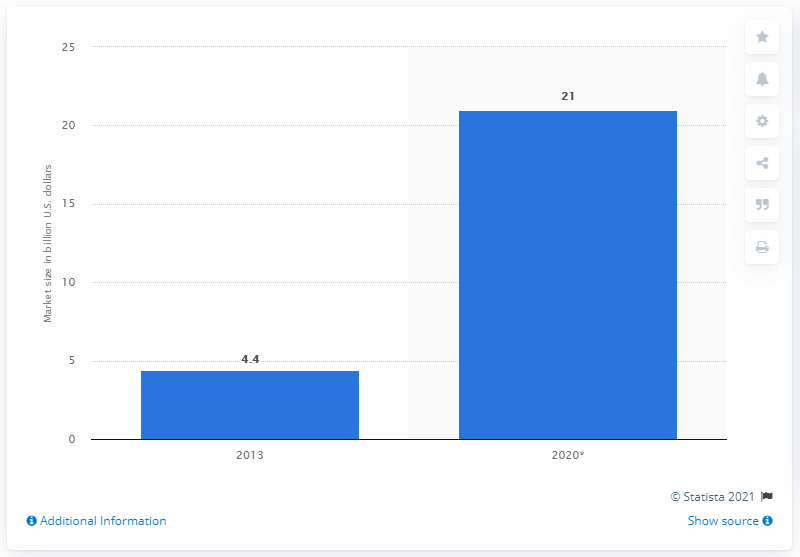Specify some key components in this picture. The global smart home automation market is expected to reach a forecasted value of [insert value] by 2020. 